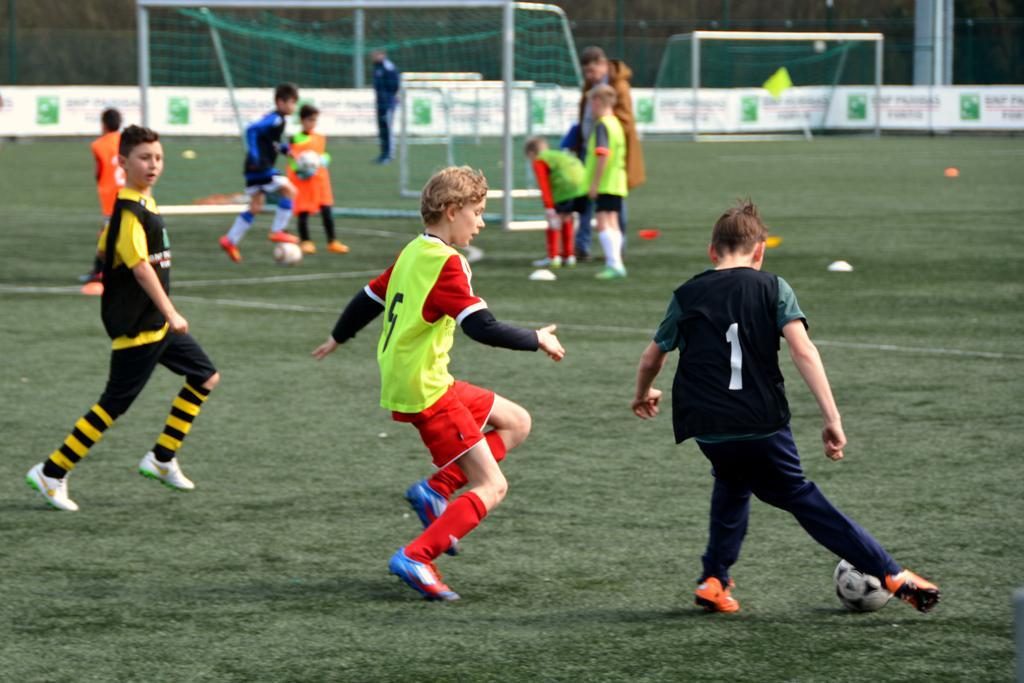Could you give a brief overview of what you see in this image? In this image I can see number of people in sports wear. Here I can see a football. 